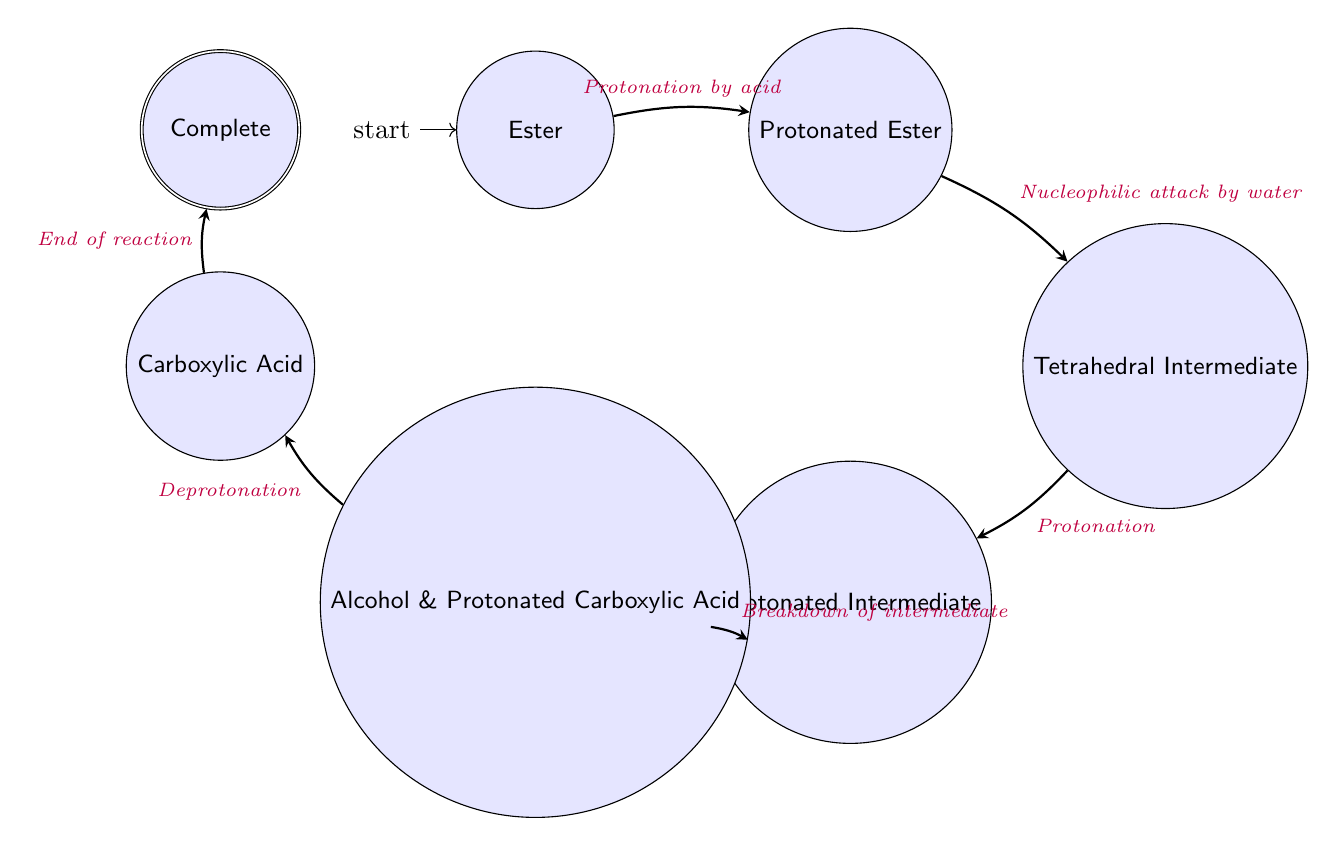What is the initial state in the diagram? The diagram indicates that the initial state is represented by the node labeled "Ester," which describes the intact ester molecule.
Answer: Ester How many states are in the diagram? By counting the labeled nodes in the diagram, there are a total of seven states depicted, including the initial state and the final accepting state.
Answer: 7 What action leads from "Protonated Ester" to "Tetrahedral Intermediate"? The transition from "Protonated Ester" to "Tetrahedral Intermediate" is facilitated by the action of a "Nucleophilic attack by water," which indicates the process involved at this stage of the reaction.
Answer: Nucleophilic attack by water Which state comes after "Alcohol and Protonated Carboxylic Acid"? You can find that the state "Carboxylic Acid" directly follows the "Alcohol and Protonated Carboxylic Acid" state in the flow of the diagram, indicating the sequence in the reaction mechanism.
Answer: Carboxylic Acid What is the final state indicated in the diagram? The diagram designates the final state of the hydrolysis process as "Complete," representing the end result of the organic reaction.
Answer: Complete What are the two products formed in the penultimate state? In the state labeled "Alcohol and Protonated Carboxylic Acid," the breakdown results in two products, specifically an alcohol and a protonated carboxylic acid, which are named in this state description.
Answer: Alcohol and Protonated Carboxylic Acid What is the transition action after "Carboxylic Acid"? Following the state "Carboxylic Acid," the diagram indicates the action "End of reaction" which signifies the conclusion of the hydrolysis process, marking the last step before completion.
Answer: End of reaction 